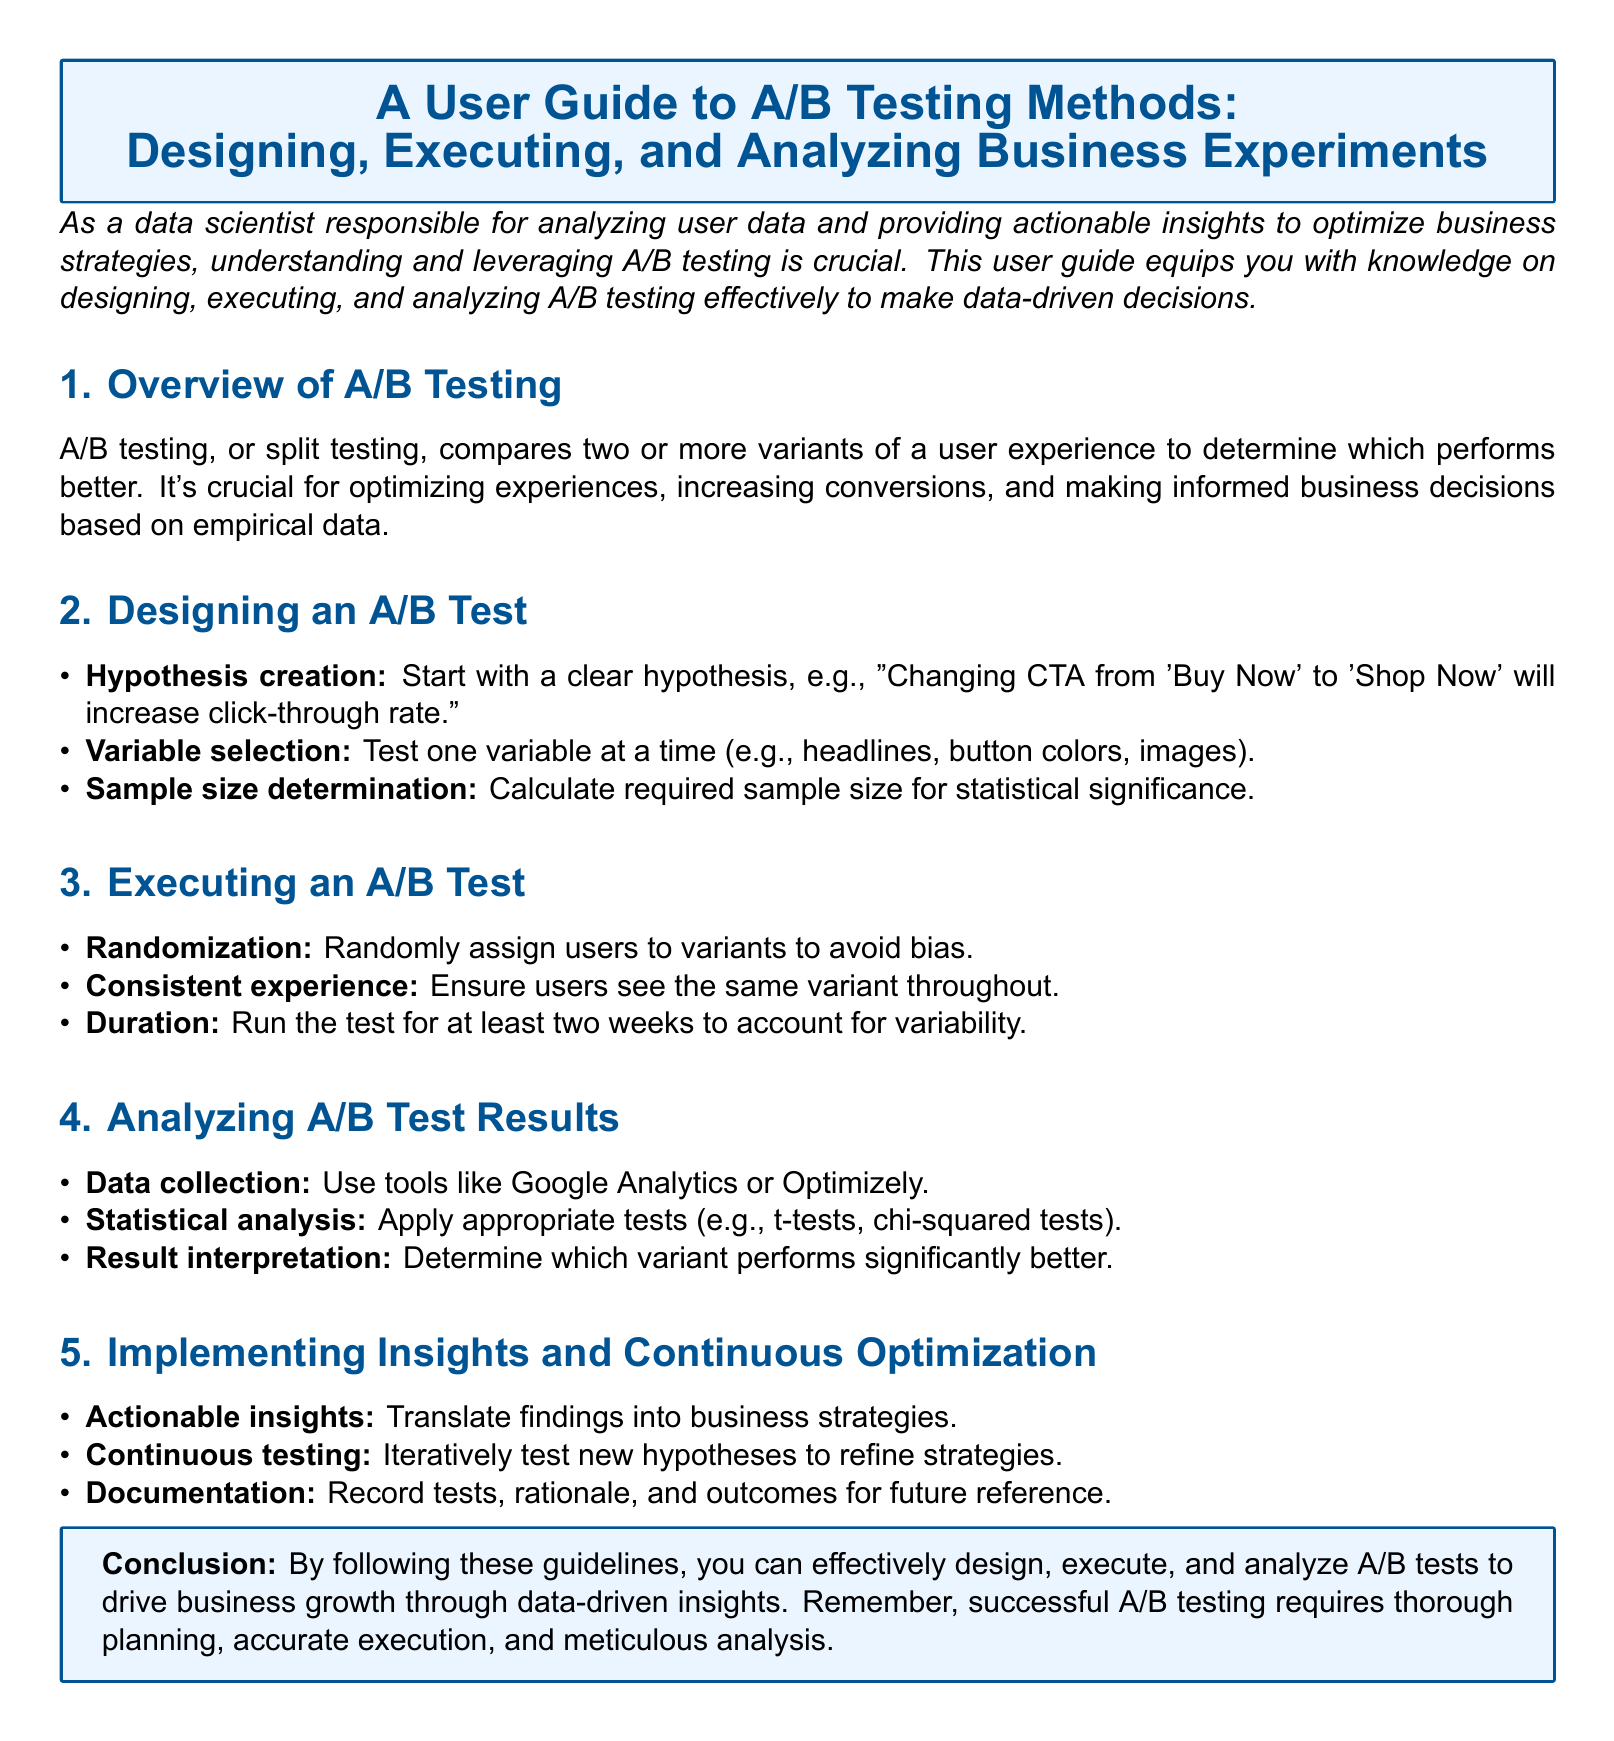What is the main purpose of A/B testing? A/B testing compares two or more variants of a user experience to determine which performs better.
Answer: To optimize experiences What is the first step in designing an A/B test? The first step is to create a clear hypothesis.
Answer: Hypothesis creation What should be tested one at a time according to the document? The document recommends testing one variable at a time.
Answer: Variable selection How long should an A/B test be run for? The document suggests running the test for at least two weeks.
Answer: Two weeks Which tools are mentioned for data collection? Google Analytics and Optimizely are mentioned for data collection.
Answer: Google Analytics, Optimizely What kind of analysis should be applied to the A/B test results? Appropriate statistical tests like t-tests or chi-squared tests should be applied.
Answer: Statistical analysis What should actionable insights be translated into? Actionable insights should be translated into business strategies.
Answer: Business strategies What is important for ensuring a consistent experience for users? Users should see the same variant throughout the test.
Answer: Consistent experience How should test outcomes be recorded? The document states that documentation should include tests, rationale, and outcomes.
Answer: Documentation 